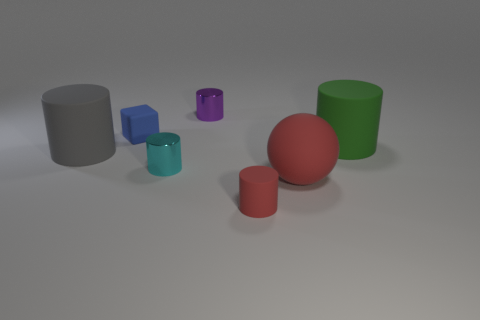Subtract all cubes. How many objects are left? 6 Subtract all tiny cyan cylinders. How many cylinders are left? 4 Subtract 3 cylinders. How many cylinders are left? 2 Add 2 small brown blocks. How many objects exist? 9 Subtract all gray cylinders. How many cylinders are left? 4 Subtract 1 cyan cylinders. How many objects are left? 6 Subtract all purple cubes. Subtract all purple cylinders. How many cubes are left? 1 Subtract all cyan spheres. How many green cylinders are left? 1 Subtract all big brown matte spheres. Subtract all big red matte objects. How many objects are left? 6 Add 1 red objects. How many red objects are left? 3 